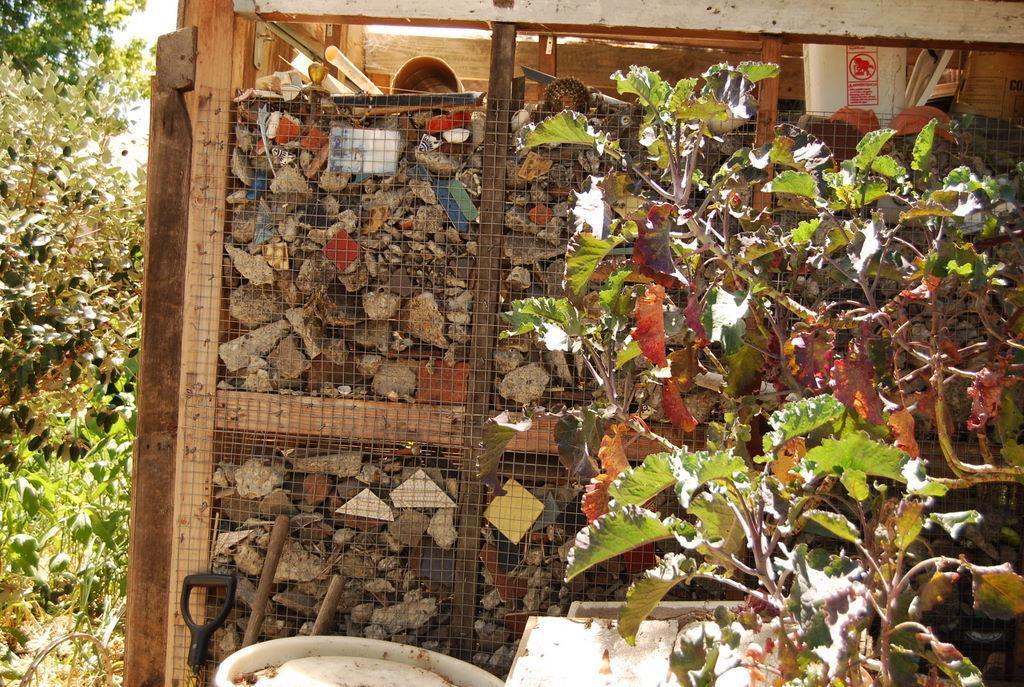Could you give a brief overview of what you see in this image? In this image we can see there is a box with stones and paper. And there are trees and box. 